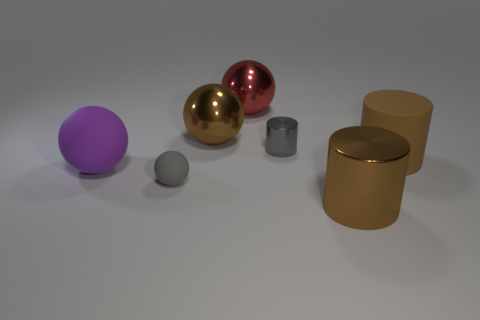Do the brown thing left of the red sphere and the red metallic ball have the same size?
Offer a terse response. Yes. What shape is the small object behind the rubber ball that is behind the small gray thing that is in front of the large brown matte cylinder?
Your response must be concise. Cylinder. How many objects are purple matte spheres or large metal things behind the brown matte object?
Provide a short and direct response. 3. What size is the matte sphere that is on the right side of the large purple rubber object?
Give a very brief answer. Small. There is a shiny object that is the same color as the large metallic cylinder; what is its shape?
Make the answer very short. Sphere. Are the brown sphere and the object in front of the tiny gray rubber thing made of the same material?
Offer a terse response. Yes. What number of tiny gray rubber balls are in front of the large cylinder to the right of the big brown cylinder in front of the gray matte object?
Your answer should be compact. 1. What number of cyan things are tiny shiny cylinders or large shiny balls?
Your response must be concise. 0. There is a gray metal object behind the large purple ball; what shape is it?
Your answer should be compact. Cylinder. There is a metallic cylinder that is the same size as the red shiny object; what is its color?
Ensure brevity in your answer.  Brown. 